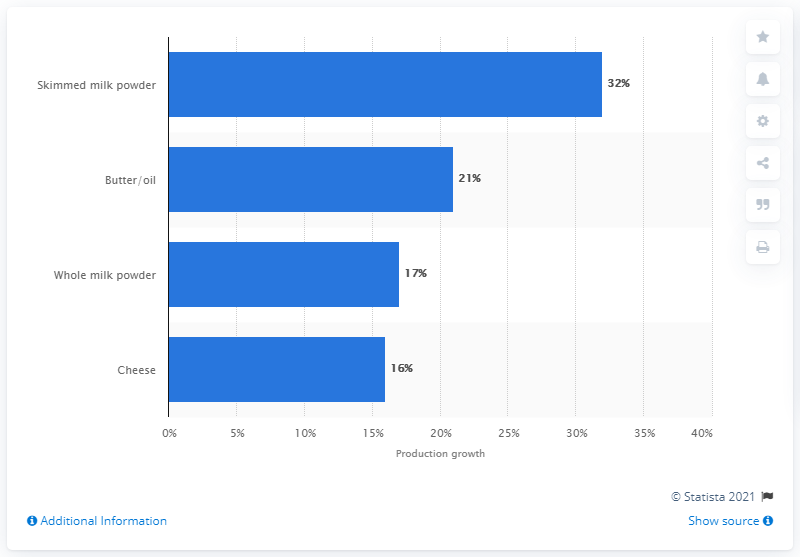Give some essential details in this illustration. The global production of cheese increased by 16% between 2010 and 2017. 